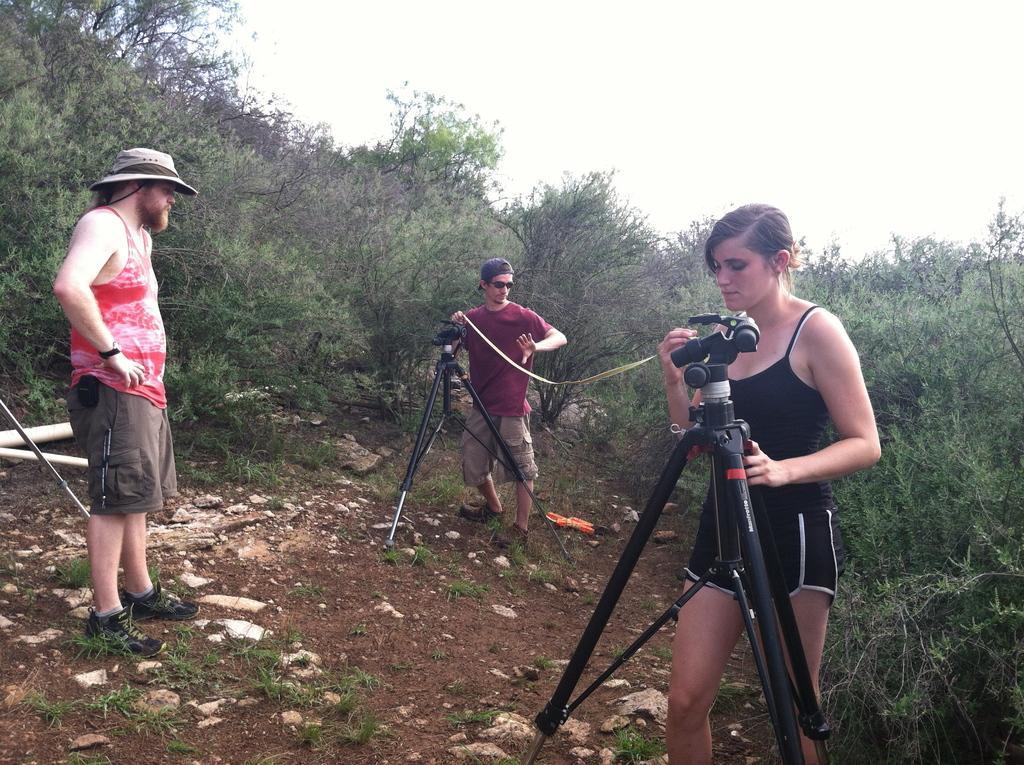Can you describe this image briefly? In this image on the right, there is a woman, she is holding a camera. In the middle there is a man, he wears a t shirt, trouser and cap, he is holding a rope. On the left there is a man, he wears a t shirt, trouser, shoes and cap. At the bottom there are stones and land. In the background there are trees and sky. 